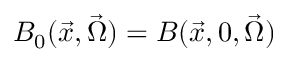<formula> <loc_0><loc_0><loc_500><loc_500>B _ { 0 } ( \vec { x } , \vec { \Omega } ) = B ( \vec { x } , 0 , \vec { \Omega } )</formula> 